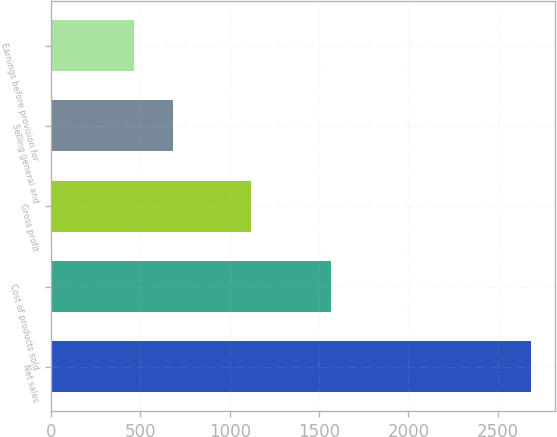Convert chart to OTSL. <chart><loc_0><loc_0><loc_500><loc_500><bar_chart><fcel>Net sales<fcel>Cost of products sold<fcel>Gross profit<fcel>Selling general and<fcel>Earnings before provision for<nl><fcel>2685.9<fcel>1566.6<fcel>1119.3<fcel>684.84<fcel>462.5<nl></chart> 